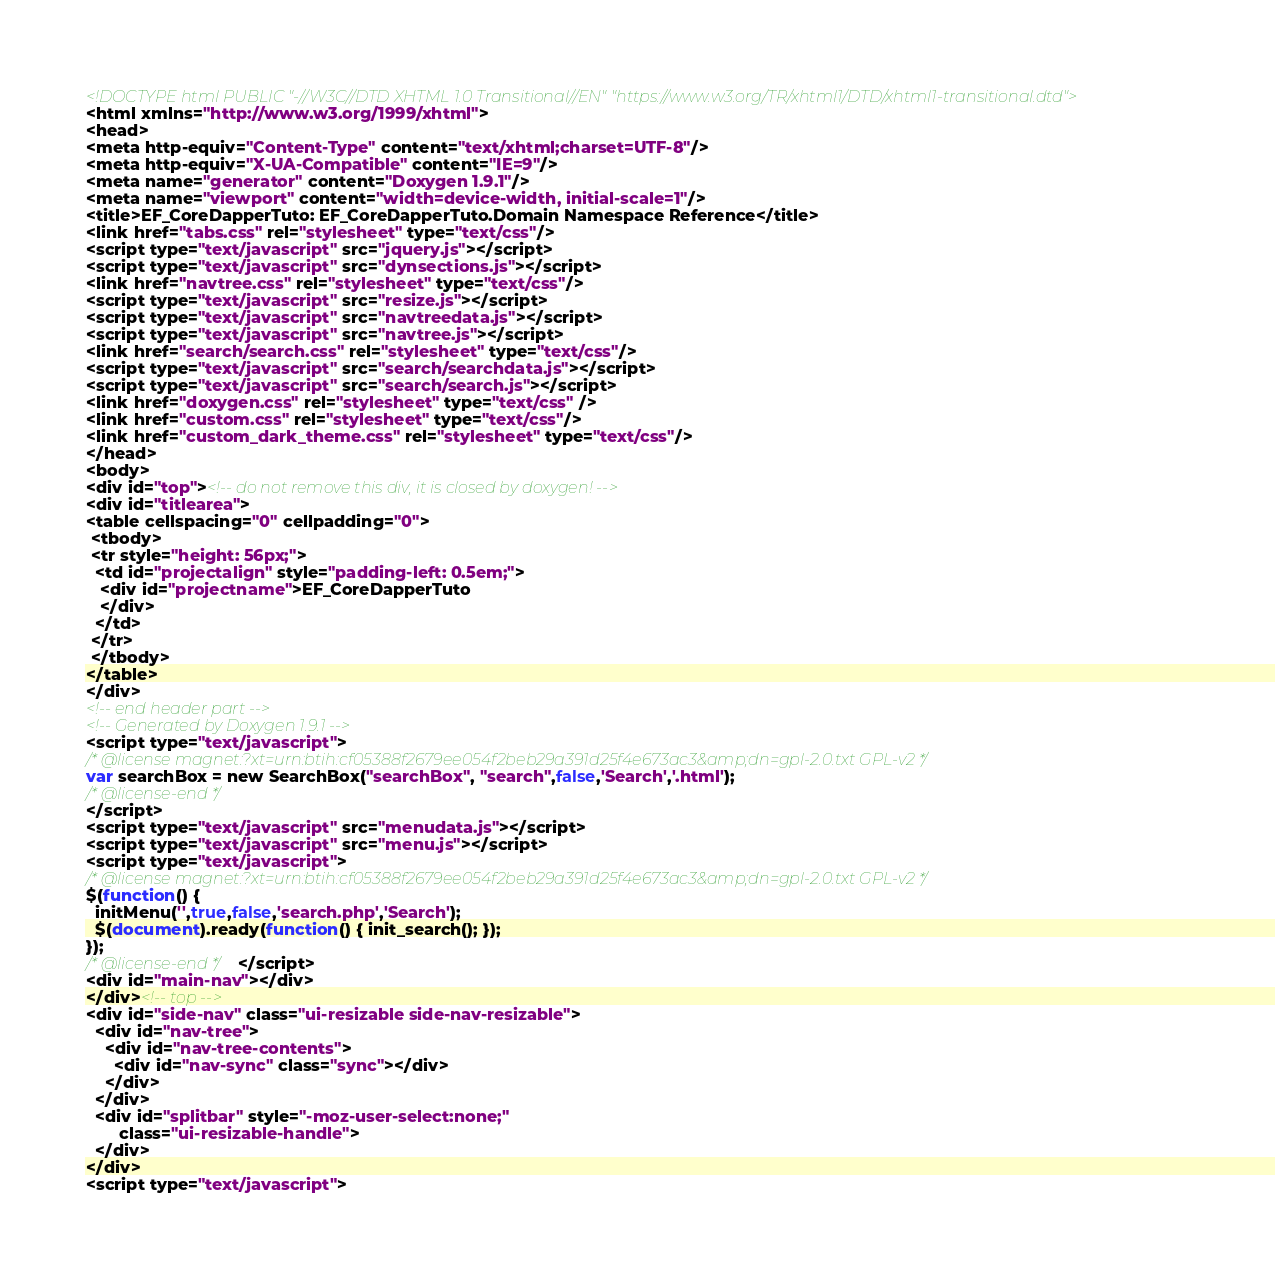<code> <loc_0><loc_0><loc_500><loc_500><_HTML_><!DOCTYPE html PUBLIC "-//W3C//DTD XHTML 1.0 Transitional//EN" "https://www.w3.org/TR/xhtml1/DTD/xhtml1-transitional.dtd">
<html xmlns="http://www.w3.org/1999/xhtml">
<head>
<meta http-equiv="Content-Type" content="text/xhtml;charset=UTF-8"/>
<meta http-equiv="X-UA-Compatible" content="IE=9"/>
<meta name="generator" content="Doxygen 1.9.1"/>
<meta name="viewport" content="width=device-width, initial-scale=1"/>
<title>EF_CoreDapperTuto: EF_CoreDapperTuto.Domain Namespace Reference</title>
<link href="tabs.css" rel="stylesheet" type="text/css"/>
<script type="text/javascript" src="jquery.js"></script>
<script type="text/javascript" src="dynsections.js"></script>
<link href="navtree.css" rel="stylesheet" type="text/css"/>
<script type="text/javascript" src="resize.js"></script>
<script type="text/javascript" src="navtreedata.js"></script>
<script type="text/javascript" src="navtree.js"></script>
<link href="search/search.css" rel="stylesheet" type="text/css"/>
<script type="text/javascript" src="search/searchdata.js"></script>
<script type="text/javascript" src="search/search.js"></script>
<link href="doxygen.css" rel="stylesheet" type="text/css" />
<link href="custom.css" rel="stylesheet" type="text/css"/>
<link href="custom_dark_theme.css" rel="stylesheet" type="text/css"/>
</head>
<body>
<div id="top"><!-- do not remove this div, it is closed by doxygen! -->
<div id="titlearea">
<table cellspacing="0" cellpadding="0">
 <tbody>
 <tr style="height: 56px;">
  <td id="projectalign" style="padding-left: 0.5em;">
   <div id="projectname">EF_CoreDapperTuto
   </div>
  </td>
 </tr>
 </tbody>
</table>
</div>
<!-- end header part -->
<!-- Generated by Doxygen 1.9.1 -->
<script type="text/javascript">
/* @license magnet:?xt=urn:btih:cf05388f2679ee054f2beb29a391d25f4e673ac3&amp;dn=gpl-2.0.txt GPL-v2 */
var searchBox = new SearchBox("searchBox", "search",false,'Search','.html');
/* @license-end */
</script>
<script type="text/javascript" src="menudata.js"></script>
<script type="text/javascript" src="menu.js"></script>
<script type="text/javascript">
/* @license magnet:?xt=urn:btih:cf05388f2679ee054f2beb29a391d25f4e673ac3&amp;dn=gpl-2.0.txt GPL-v2 */
$(function() {
  initMenu('',true,false,'search.php','Search');
  $(document).ready(function() { init_search(); });
});
/* @license-end */</script>
<div id="main-nav"></div>
</div><!-- top -->
<div id="side-nav" class="ui-resizable side-nav-resizable">
  <div id="nav-tree">
    <div id="nav-tree-contents">
      <div id="nav-sync" class="sync"></div>
    </div>
  </div>
  <div id="splitbar" style="-moz-user-select:none;" 
       class="ui-resizable-handle">
  </div>
</div>
<script type="text/javascript"></code> 